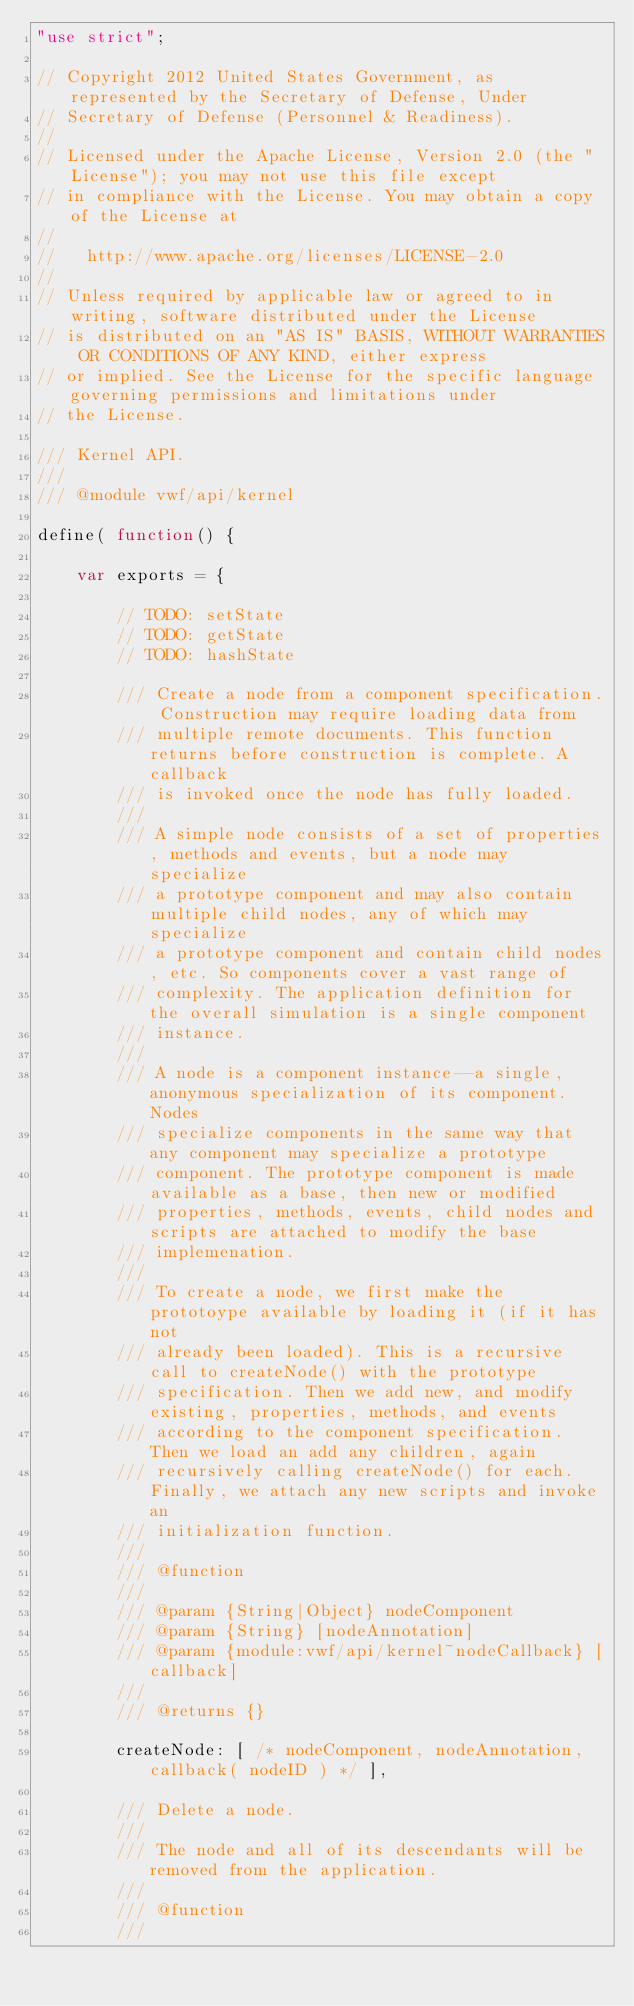Convert code to text. <code><loc_0><loc_0><loc_500><loc_500><_JavaScript_>"use strict";

// Copyright 2012 United States Government, as represented by the Secretary of Defense, Under
// Secretary of Defense (Personnel & Readiness).
// 
// Licensed under the Apache License, Version 2.0 (the "License"); you may not use this file except
// in compliance with the License. You may obtain a copy of the License at
// 
//   http://www.apache.org/licenses/LICENSE-2.0
// 
// Unless required by applicable law or agreed to in writing, software distributed under the License
// is distributed on an "AS IS" BASIS, WITHOUT WARRANTIES OR CONDITIONS OF ANY KIND, either express
// or implied. See the License for the specific language governing permissions and limitations under
// the License.

/// Kernel API.
/// 
/// @module vwf/api/kernel

define( function() {

    var exports = {

        // TODO: setState
        // TODO: getState
        // TODO: hashState

        /// Create a node from a component specification. Construction may require loading data from
        /// multiple remote documents. This function returns before construction is complete. A callback
        /// is invoked once the node has fully loaded.
        /// 
        /// A simple node consists of a set of properties, methods and events, but a node may specialize
        /// a prototype component and may also contain multiple child nodes, any of which may specialize
        /// a prototype component and contain child nodes, etc. So components cover a vast range of
        /// complexity. The application definition for the overall simulation is a single component
        /// instance.
        /// 
        /// A node is a component instance--a single, anonymous specialization of its component. Nodes
        /// specialize components in the same way that any component may specialize a prototype
        /// component. The prototype component is made available as a base, then new or modified
        /// properties, methods, events, child nodes and scripts are attached to modify the base
        /// implemenation.
        /// 
        /// To create a node, we first make the prototoype available by loading it (if it has not
        /// already been loaded). This is a recursive call to createNode() with the prototype
        /// specification. Then we add new, and modify existing, properties, methods, and events
        /// according to the component specification. Then we load an add any children, again
        /// recursively calling createNode() for each. Finally, we attach any new scripts and invoke an
        /// initialization function.
        /// 
        /// @function
        /// 
        /// @param {String|Object} nodeComponent
        /// @param {String} [nodeAnnotation]
        /// @param {module:vwf/api/kernel~nodeCallback} [callback]
        /// 
        /// @returns {}

        createNode: [ /* nodeComponent, nodeAnnotation, callback( nodeID ) */ ],

        /// Delete a node.
        /// 
        /// The node and all of its descendants will be removed from the application.
        /// 
        /// @function
        /// </code> 